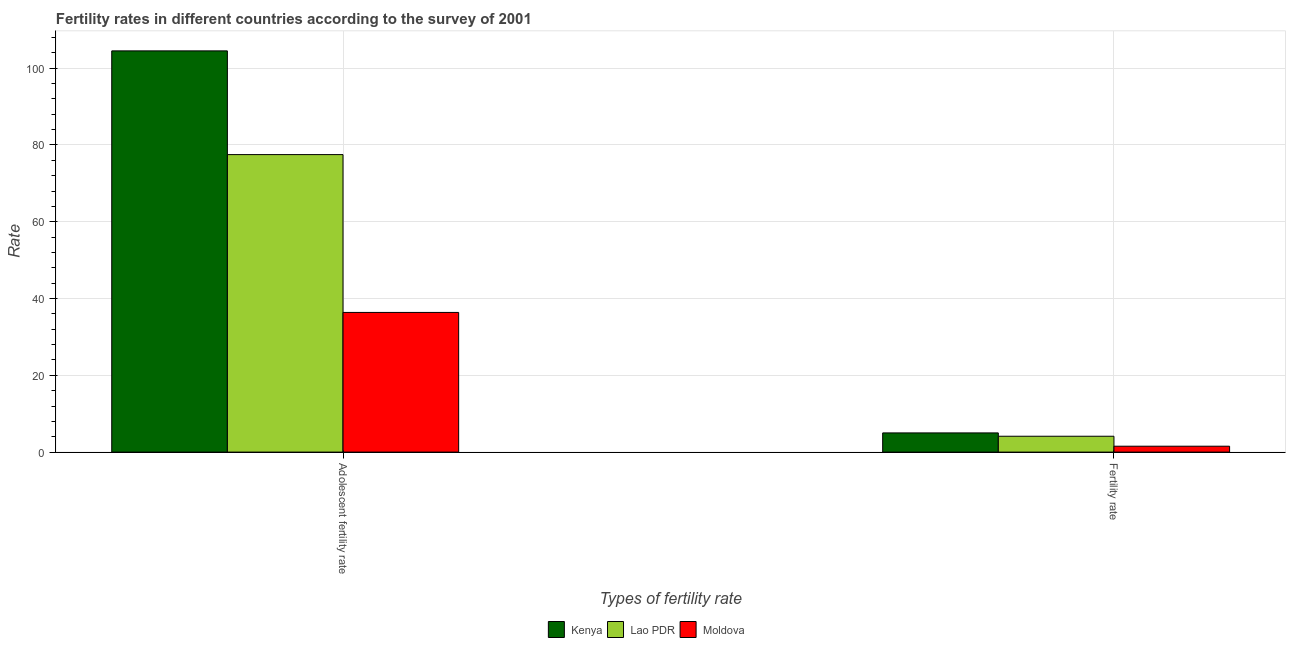How many different coloured bars are there?
Offer a terse response. 3. Are the number of bars per tick equal to the number of legend labels?
Provide a short and direct response. Yes. Are the number of bars on each tick of the X-axis equal?
Ensure brevity in your answer.  Yes. What is the label of the 1st group of bars from the left?
Provide a succinct answer. Adolescent fertility rate. What is the fertility rate in Moldova?
Give a very brief answer. 1.53. Across all countries, what is the maximum adolescent fertility rate?
Offer a terse response. 104.5. Across all countries, what is the minimum adolescent fertility rate?
Give a very brief answer. 36.38. In which country was the adolescent fertility rate maximum?
Provide a succinct answer. Kenya. In which country was the adolescent fertility rate minimum?
Offer a very short reply. Moldova. What is the total fertility rate in the graph?
Provide a succinct answer. 10.67. What is the difference between the adolescent fertility rate in Lao PDR and that in Kenya?
Make the answer very short. -27.02. What is the difference between the adolescent fertility rate in Kenya and the fertility rate in Lao PDR?
Your answer should be compact. 100.37. What is the average adolescent fertility rate per country?
Give a very brief answer. 72.79. What is the difference between the fertility rate and adolescent fertility rate in Lao PDR?
Make the answer very short. -73.35. In how many countries, is the fertility rate greater than 96 ?
Your answer should be very brief. 0. What is the ratio of the fertility rate in Kenya to that in Lao PDR?
Offer a very short reply. 1.21. Is the adolescent fertility rate in Kenya less than that in Lao PDR?
Provide a succinct answer. No. In how many countries, is the adolescent fertility rate greater than the average adolescent fertility rate taken over all countries?
Give a very brief answer. 2. What does the 2nd bar from the left in Adolescent fertility rate represents?
Offer a very short reply. Lao PDR. What does the 1st bar from the right in Adolescent fertility rate represents?
Provide a short and direct response. Moldova. How many bars are there?
Offer a very short reply. 6. Are all the bars in the graph horizontal?
Give a very brief answer. No. How many countries are there in the graph?
Make the answer very short. 3. Are the values on the major ticks of Y-axis written in scientific E-notation?
Make the answer very short. No. Where does the legend appear in the graph?
Your response must be concise. Bottom center. How many legend labels are there?
Provide a succinct answer. 3. What is the title of the graph?
Make the answer very short. Fertility rates in different countries according to the survey of 2001. What is the label or title of the X-axis?
Provide a succinct answer. Types of fertility rate. What is the label or title of the Y-axis?
Provide a short and direct response. Rate. What is the Rate in Kenya in Adolescent fertility rate?
Provide a short and direct response. 104.5. What is the Rate in Lao PDR in Adolescent fertility rate?
Ensure brevity in your answer.  77.48. What is the Rate in Moldova in Adolescent fertility rate?
Your answer should be very brief. 36.38. What is the Rate of Kenya in Fertility rate?
Ensure brevity in your answer.  5. What is the Rate in Lao PDR in Fertility rate?
Your response must be concise. 4.13. What is the Rate of Moldova in Fertility rate?
Your answer should be very brief. 1.53. Across all Types of fertility rate, what is the maximum Rate of Kenya?
Make the answer very short. 104.5. Across all Types of fertility rate, what is the maximum Rate of Lao PDR?
Your answer should be compact. 77.48. Across all Types of fertility rate, what is the maximum Rate of Moldova?
Offer a terse response. 36.38. Across all Types of fertility rate, what is the minimum Rate of Lao PDR?
Give a very brief answer. 4.13. Across all Types of fertility rate, what is the minimum Rate in Moldova?
Provide a succinct answer. 1.53. What is the total Rate of Kenya in the graph?
Your answer should be compact. 109.5. What is the total Rate of Lao PDR in the graph?
Give a very brief answer. 81.62. What is the total Rate of Moldova in the graph?
Provide a succinct answer. 37.91. What is the difference between the Rate in Kenya in Adolescent fertility rate and that in Fertility rate?
Offer a very short reply. 99.5. What is the difference between the Rate of Lao PDR in Adolescent fertility rate and that in Fertility rate?
Make the answer very short. 73.35. What is the difference between the Rate in Moldova in Adolescent fertility rate and that in Fertility rate?
Make the answer very short. 34.84. What is the difference between the Rate of Kenya in Adolescent fertility rate and the Rate of Lao PDR in Fertility rate?
Your response must be concise. 100.37. What is the difference between the Rate in Kenya in Adolescent fertility rate and the Rate in Moldova in Fertility rate?
Provide a short and direct response. 102.97. What is the difference between the Rate in Lao PDR in Adolescent fertility rate and the Rate in Moldova in Fertility rate?
Your response must be concise. 75.95. What is the average Rate of Kenya per Types of fertility rate?
Keep it short and to the point. 54.75. What is the average Rate of Lao PDR per Types of fertility rate?
Provide a short and direct response. 40.81. What is the average Rate in Moldova per Types of fertility rate?
Make the answer very short. 18.96. What is the difference between the Rate of Kenya and Rate of Lao PDR in Adolescent fertility rate?
Ensure brevity in your answer.  27.02. What is the difference between the Rate in Kenya and Rate in Moldova in Adolescent fertility rate?
Your response must be concise. 68.12. What is the difference between the Rate in Lao PDR and Rate in Moldova in Adolescent fertility rate?
Your answer should be compact. 41.11. What is the difference between the Rate of Kenya and Rate of Lao PDR in Fertility rate?
Give a very brief answer. 0.87. What is the difference between the Rate of Kenya and Rate of Moldova in Fertility rate?
Your response must be concise. 3.46. What is the difference between the Rate of Lao PDR and Rate of Moldova in Fertility rate?
Offer a terse response. 2.6. What is the ratio of the Rate of Kenya in Adolescent fertility rate to that in Fertility rate?
Your response must be concise. 20.9. What is the ratio of the Rate in Lao PDR in Adolescent fertility rate to that in Fertility rate?
Offer a very short reply. 18.75. What is the ratio of the Rate of Moldova in Adolescent fertility rate to that in Fertility rate?
Ensure brevity in your answer.  23.7. What is the difference between the highest and the second highest Rate of Kenya?
Keep it short and to the point. 99.5. What is the difference between the highest and the second highest Rate of Lao PDR?
Give a very brief answer. 73.35. What is the difference between the highest and the second highest Rate of Moldova?
Keep it short and to the point. 34.84. What is the difference between the highest and the lowest Rate of Kenya?
Provide a succinct answer. 99.5. What is the difference between the highest and the lowest Rate in Lao PDR?
Your answer should be compact. 73.35. What is the difference between the highest and the lowest Rate in Moldova?
Make the answer very short. 34.84. 